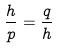Convert formula to latex. <formula><loc_0><loc_0><loc_500><loc_500>\frac { h } { p } = \frac { q } { h }</formula> 